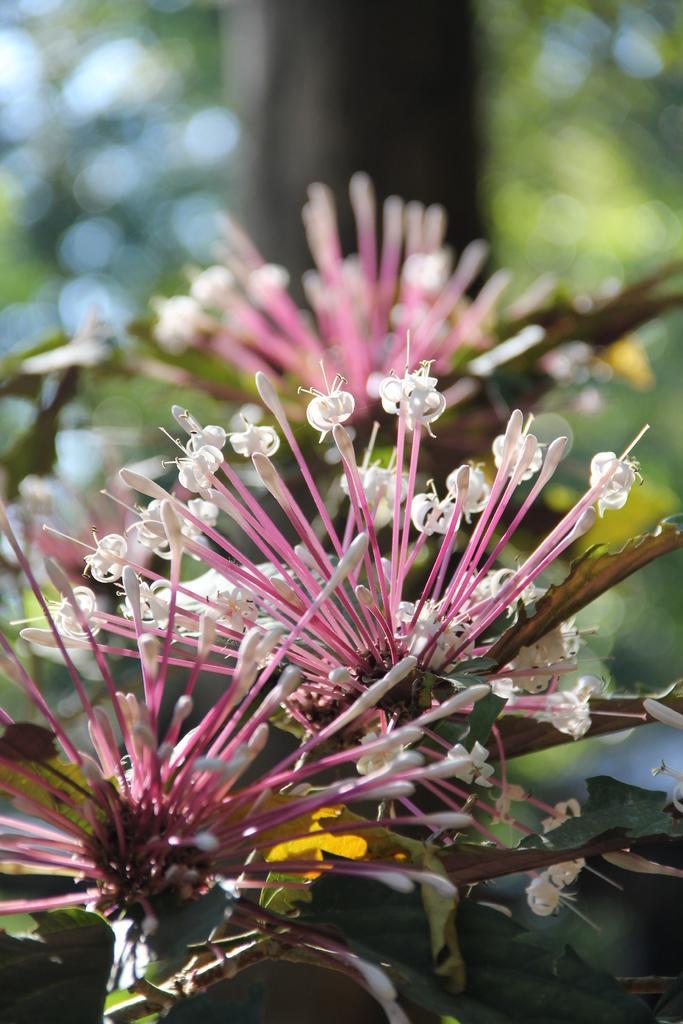Can you describe this image briefly? In the foreground of this image, there are flowers to the plant and in the background, there is a tree. 